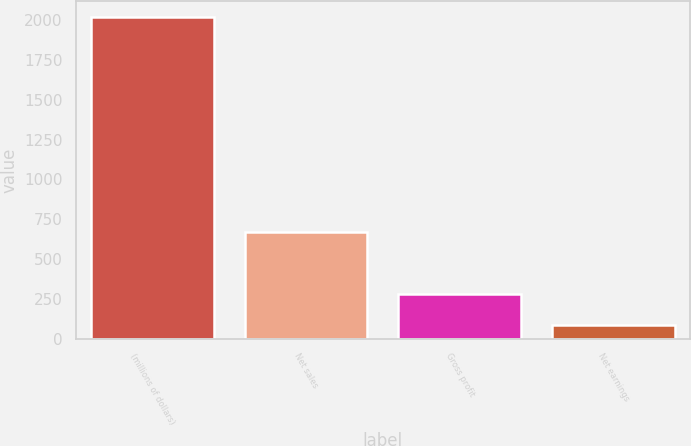Convert chart to OTSL. <chart><loc_0><loc_0><loc_500><loc_500><bar_chart><fcel>(millions of dollars)<fcel>Net sales<fcel>Gross profit<fcel>Net earnings<nl><fcel>2017<fcel>669.6<fcel>278.38<fcel>85.2<nl></chart> 